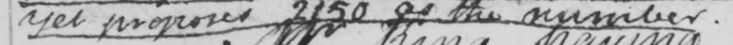Please transcribe the handwritten text in this image. yet proposes 2150 as the number . 